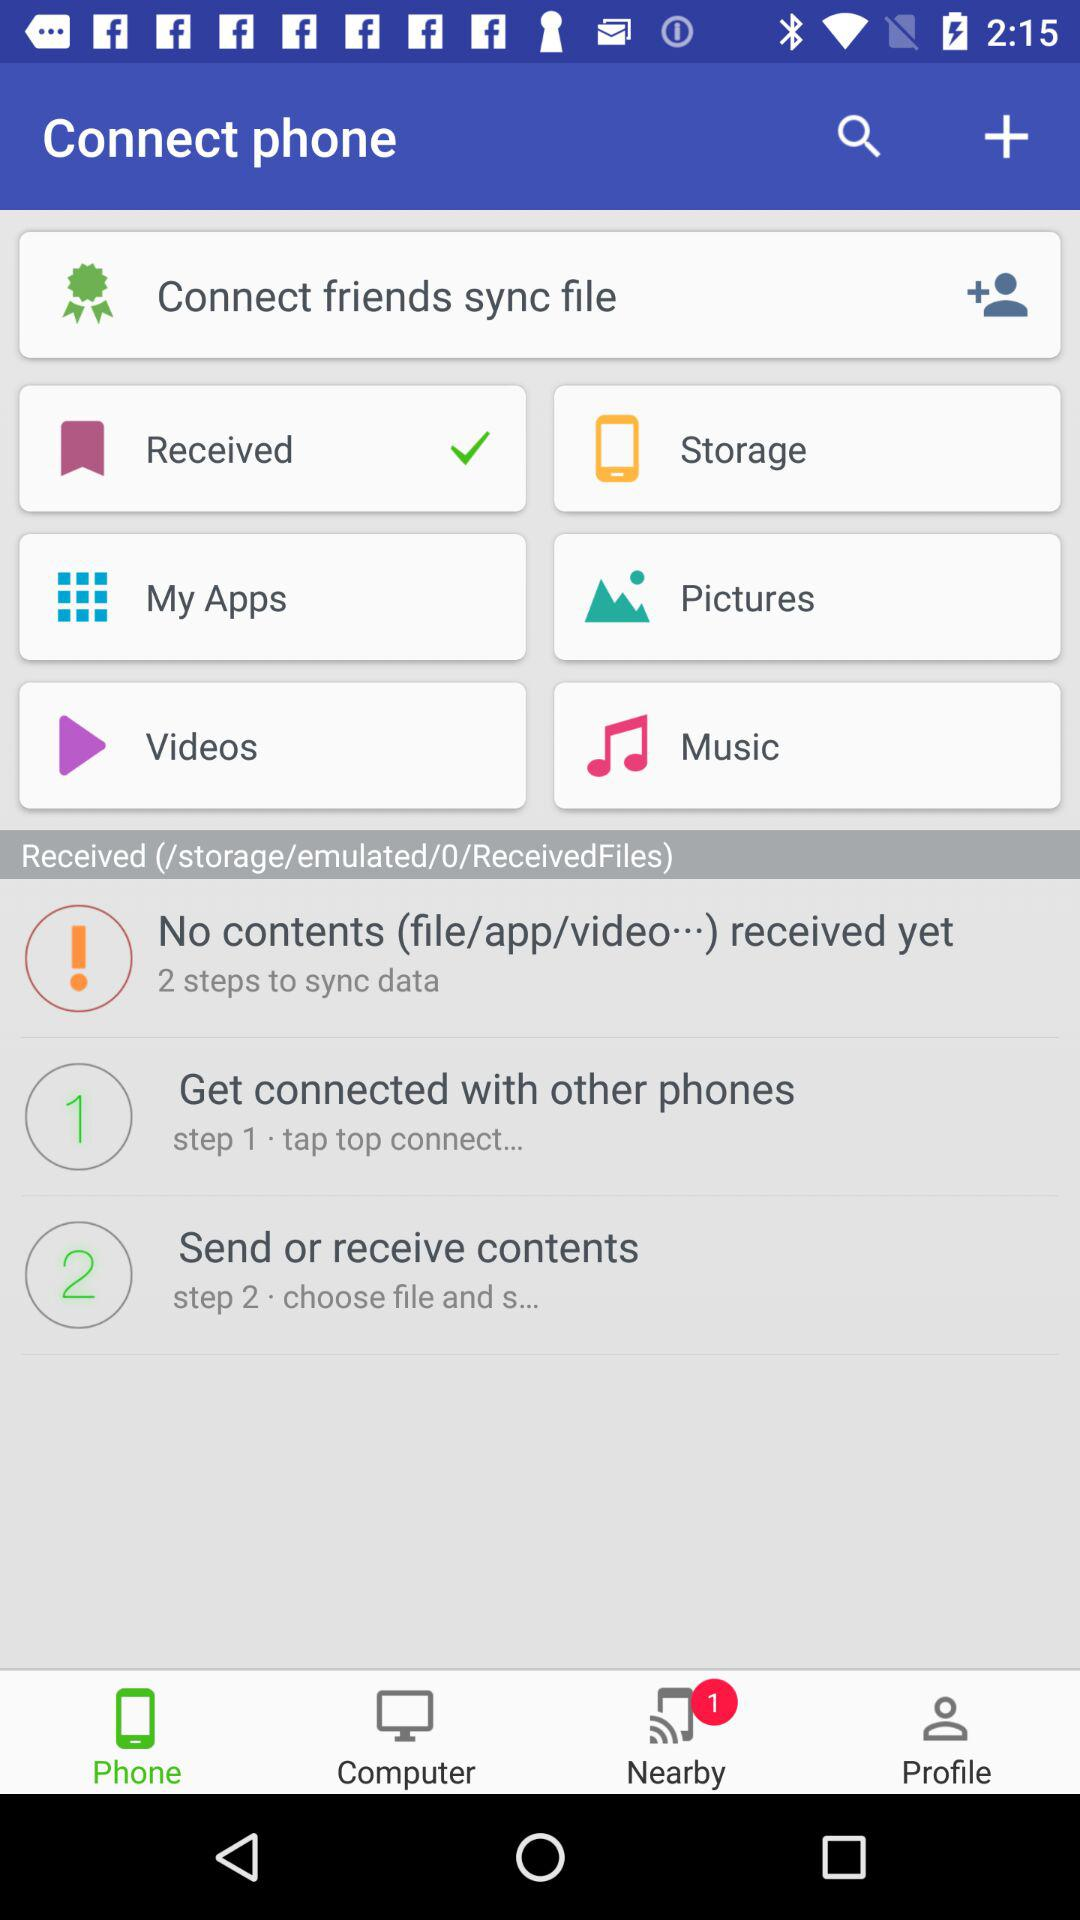How many devices are available for connecting? The number of available devices is 1. 